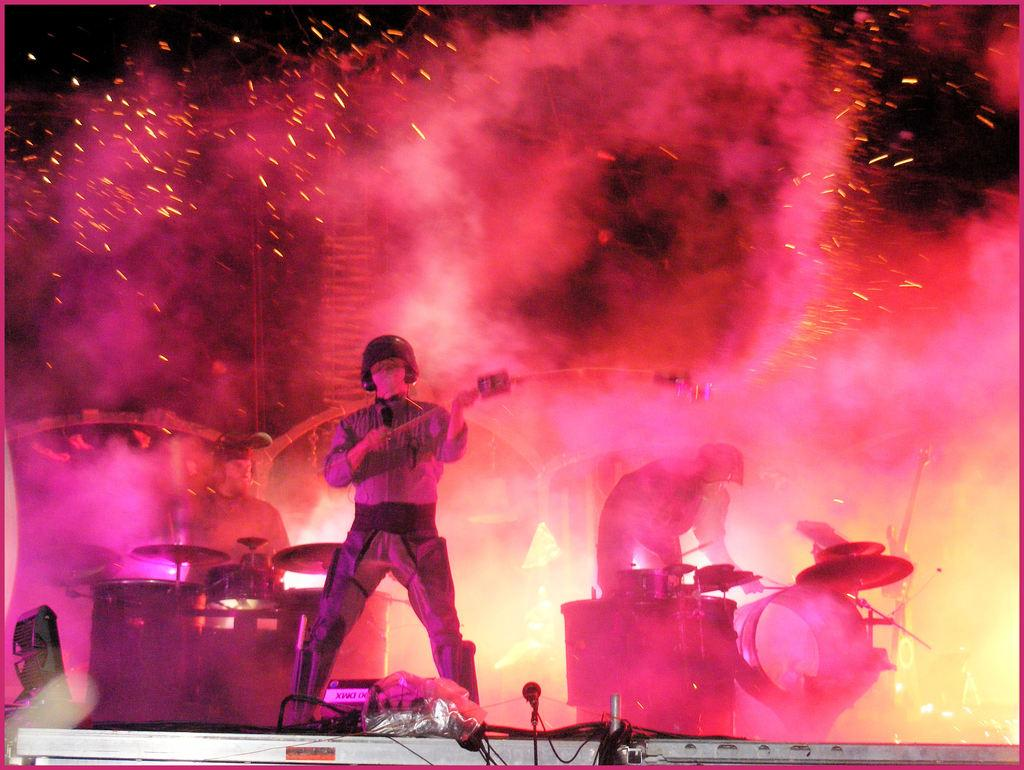What is the person in the image wearing on their head? The person in the image is wearing a helmet. What is the person holding in their hands? The person is holding an object in their hands. What activity are the two persons in the background engaged in? The two persons in the background are playing musical instruments. What type of glue is being used to hold the plot together in the image? There is no glue or plot present in the image; it features a person wearing a helmet and two persons playing musical instruments in the background. 